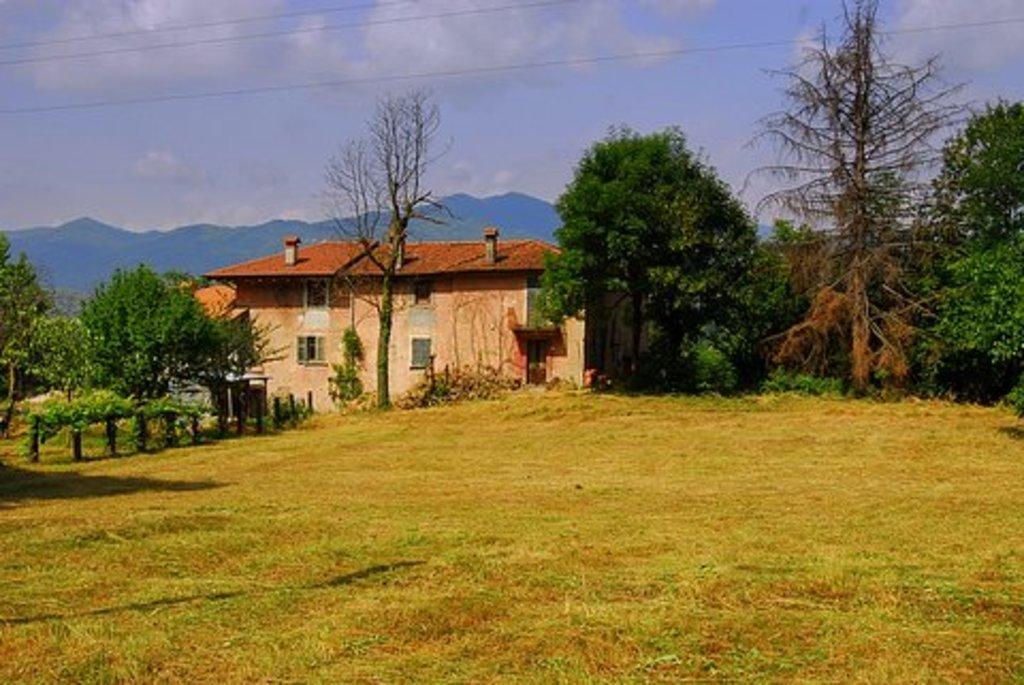Describe this image in one or two sentences. In this picture we can see house, trees, grass and hills. 